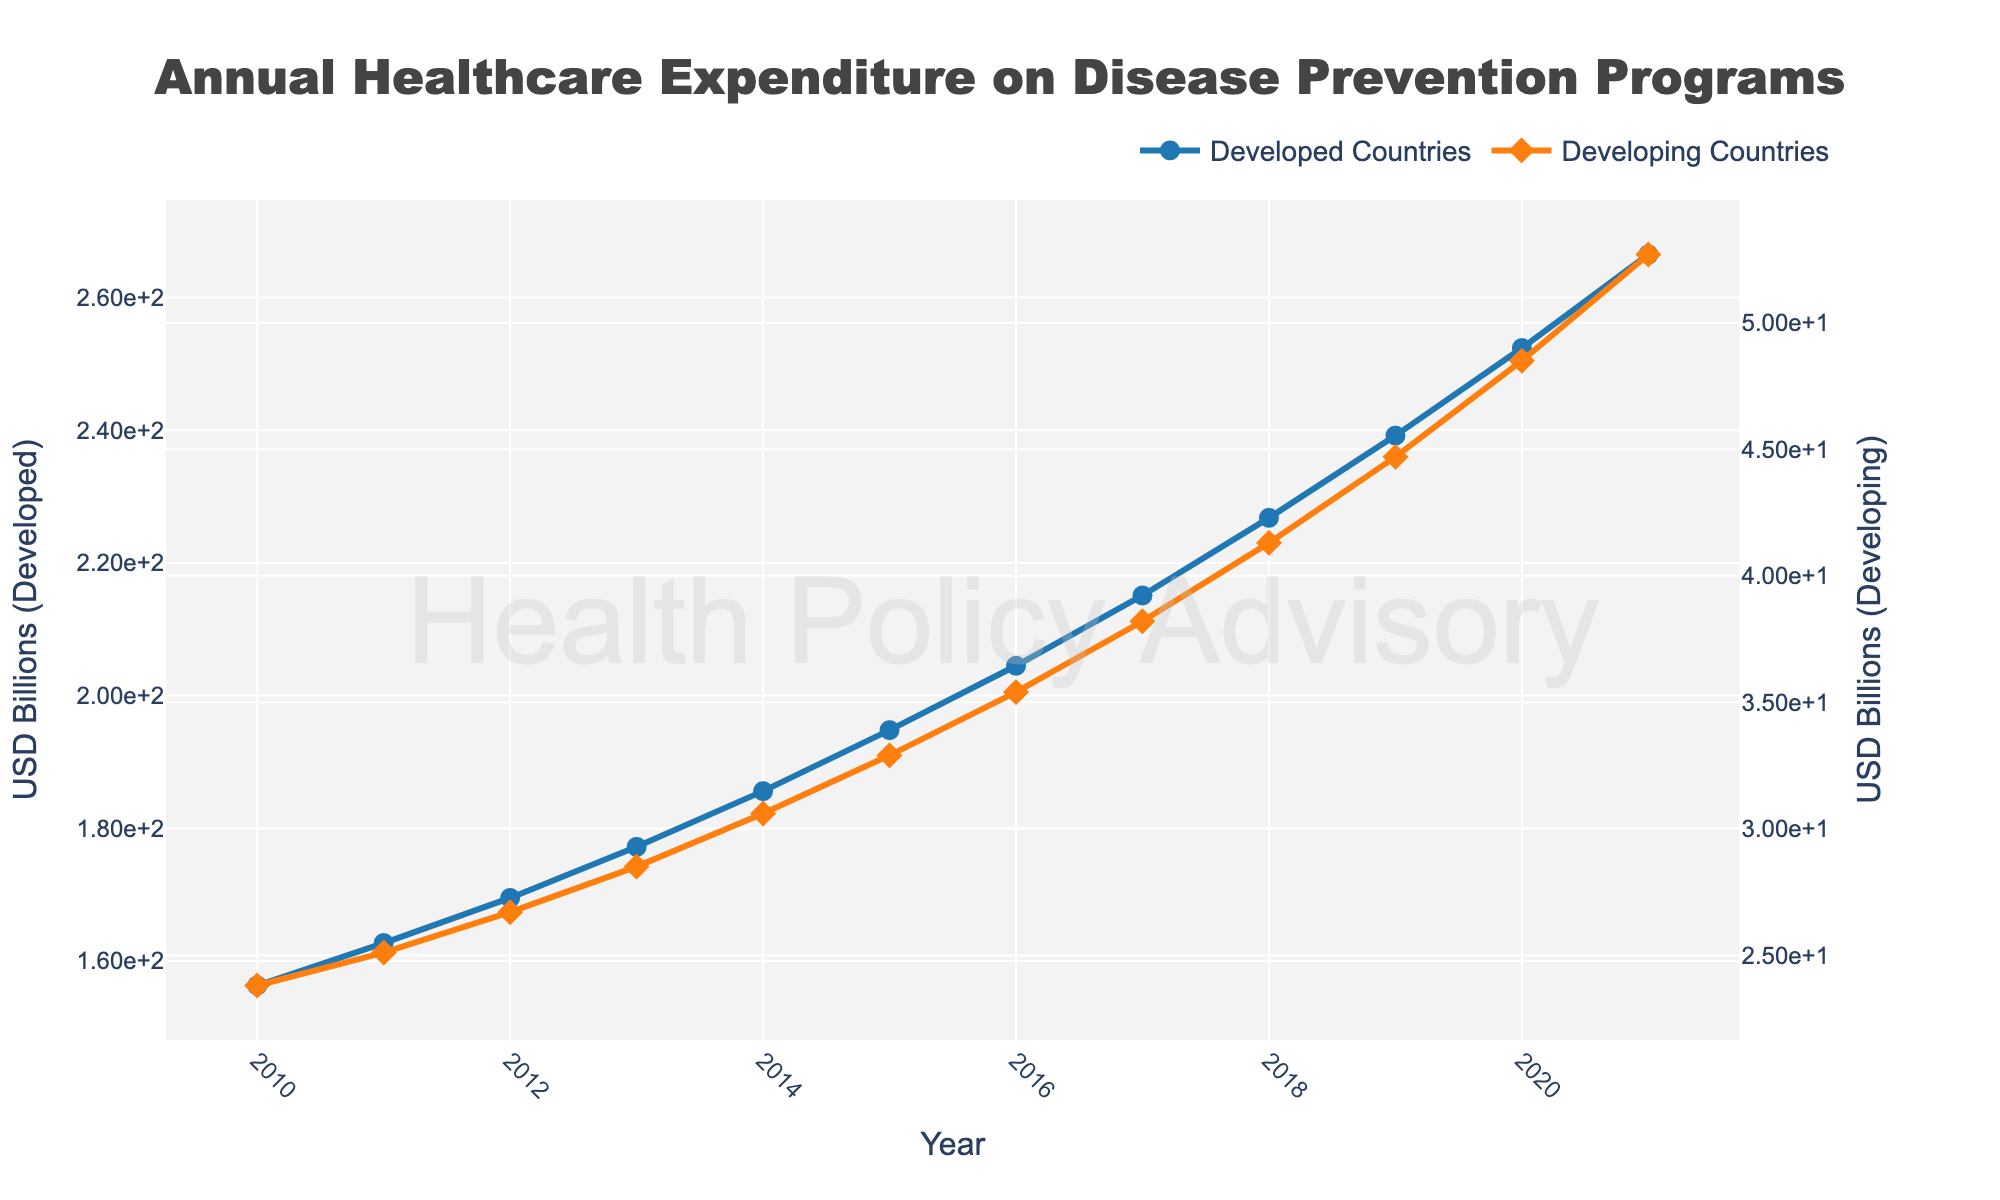Which country had higher healthcare expenditure on disease prevention programs in 2017? Locate the year 2017 on the x-axis. Compare the y-values of the lines for "Developed Countries" and "Developing Countries". The value for Developed Countries is higher.
Answer: Developed Countries What was the difference in healthcare expenditure between developed and developing countries in 2020? Locate the year 2020 on the x-axis. Note the y-values for "Developed Countries" and "Developing Countries". Subtract the value for Developing Countries from that for Developed Countries: 252.4 - 48.5 = 203.9.
Answer: 203.9 By how much did the healthcare expenditure of developed countries increase from 2010 to 2021? Locate the years 2010 and 2021 on the x-axis. Note the y-values for "Developed Countries" in both years. Subtract the 2010 value from the 2021 value: 266.5 - 156.3 = 110.2.
Answer: 110.2 In which year did developing countries surpass USD 40 billion in healthcare expenditure on disease prevention programs? Locate the values of "Developing Countries" on the y-axis and find the year when the y-value first exceeds 40 billion. This happens in 2018.
Answer: 2018 What is the average healthcare expenditure of developed countries from 2010 to 2021? Add the y-values for "Developed Countries" from 2010 to 2021 and divide by the number of years (12): (156.3 + 162.7 + 169.5 + 177.2 + 185.6 + 194.8 + 204.5 + 215.1 + 226.8 + 239.2 + 252.4 + 266.5) / 12 ≈ 202.55.
Answer: 202.55 Which country's expenditure is growing at a faster rate: developed or developing countries? Visually assess the steepness of the lines. The line for developing countries has a steeper slope compared to the line for developed countries. This suggests a faster growth rate for developing countries.
Answer: Developing Countries Describe the overall trend in healthcare expenditure for both developed and developing countries from 2010 to 2021. Both lines are upward sloping, indicating an increase in expenditure over time. Developed countries have a higher expenditure throughout but developing countries also show a steady incline.
Answer: Increasing for both At what year did the healthcare expenditure of developing countries reach approximately 30 billion USD? Locate the y-values for "Developing Countries" and find the year when it is closest to 30 billion. This occurs in 2014.
Answer: 2014 